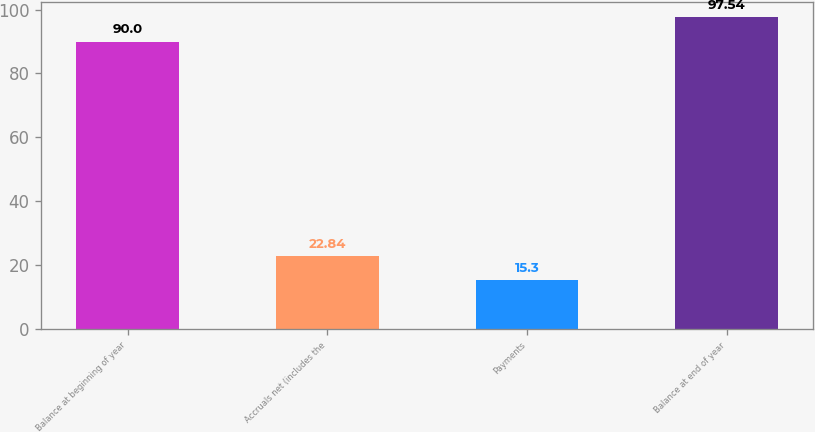<chart> <loc_0><loc_0><loc_500><loc_500><bar_chart><fcel>Balance at beginning of year<fcel>Accruals net (includes the<fcel>Payments<fcel>Balance at end of year<nl><fcel>90<fcel>22.84<fcel>15.3<fcel>97.54<nl></chart> 